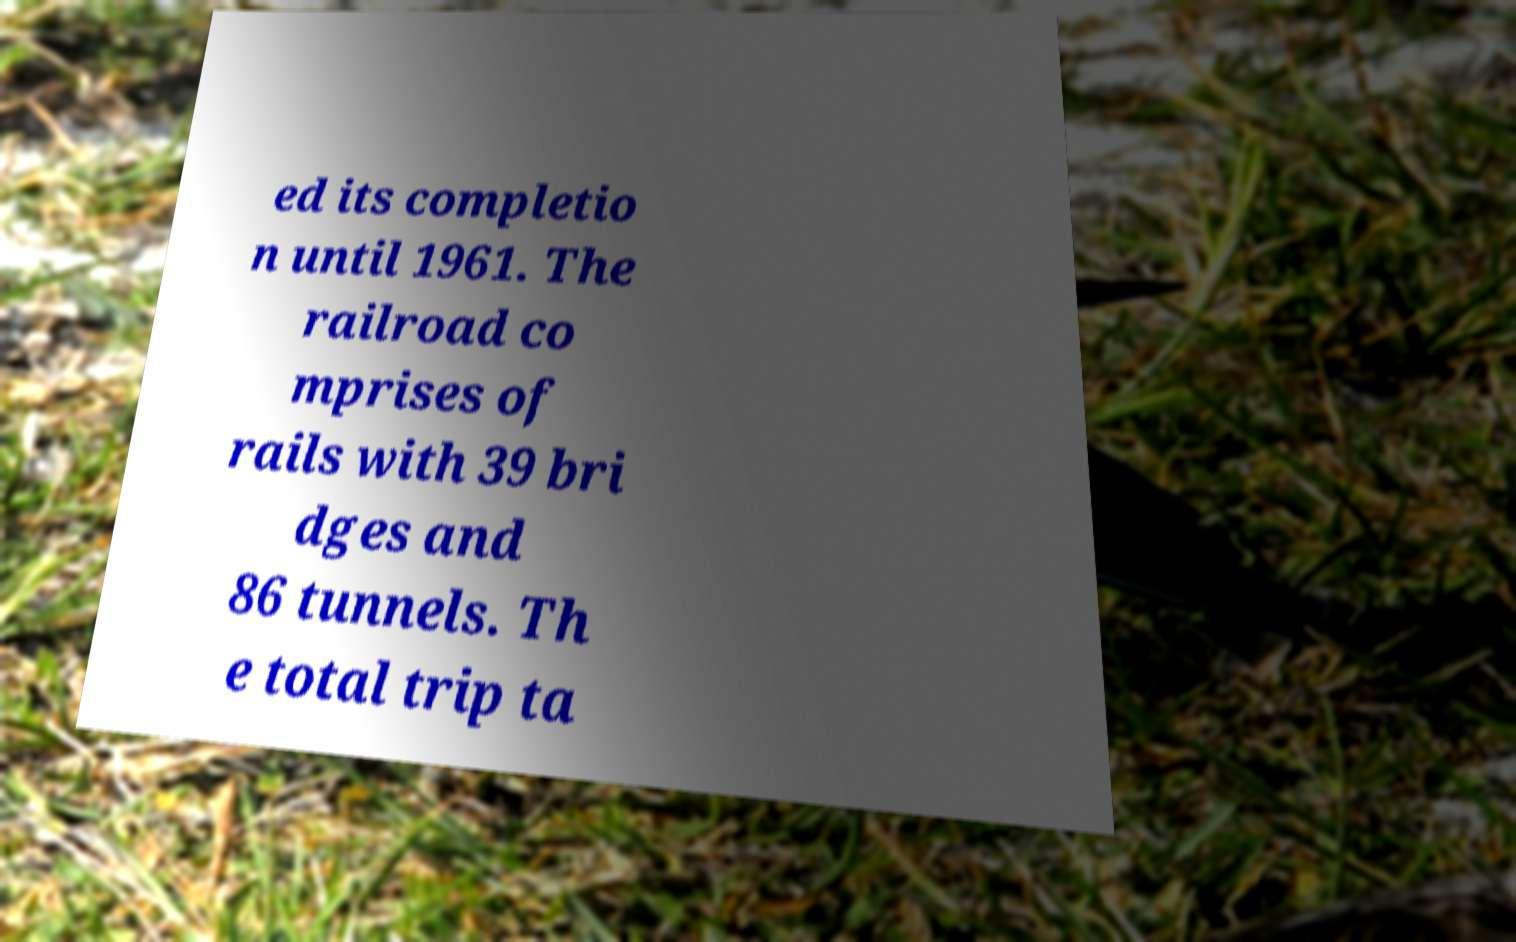Please read and relay the text visible in this image. What does it say? ed its completio n until 1961. The railroad co mprises of rails with 39 bri dges and 86 tunnels. Th e total trip ta 